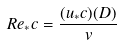Convert formula to latex. <formula><loc_0><loc_0><loc_500><loc_500>R e _ { * } c = \frac { ( u _ { * } c ) ( D ) } { v }</formula> 